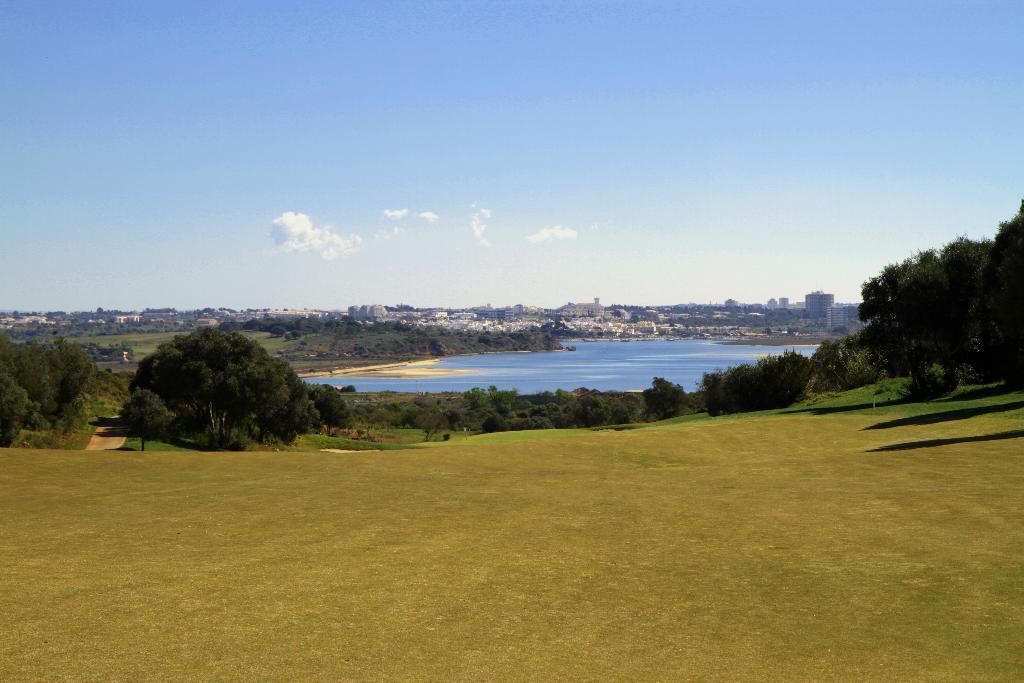Can you describe this image briefly? In this image we can see grass on the ground, trees and water. In the background we can see buildings, trees and clouds in the sky. 